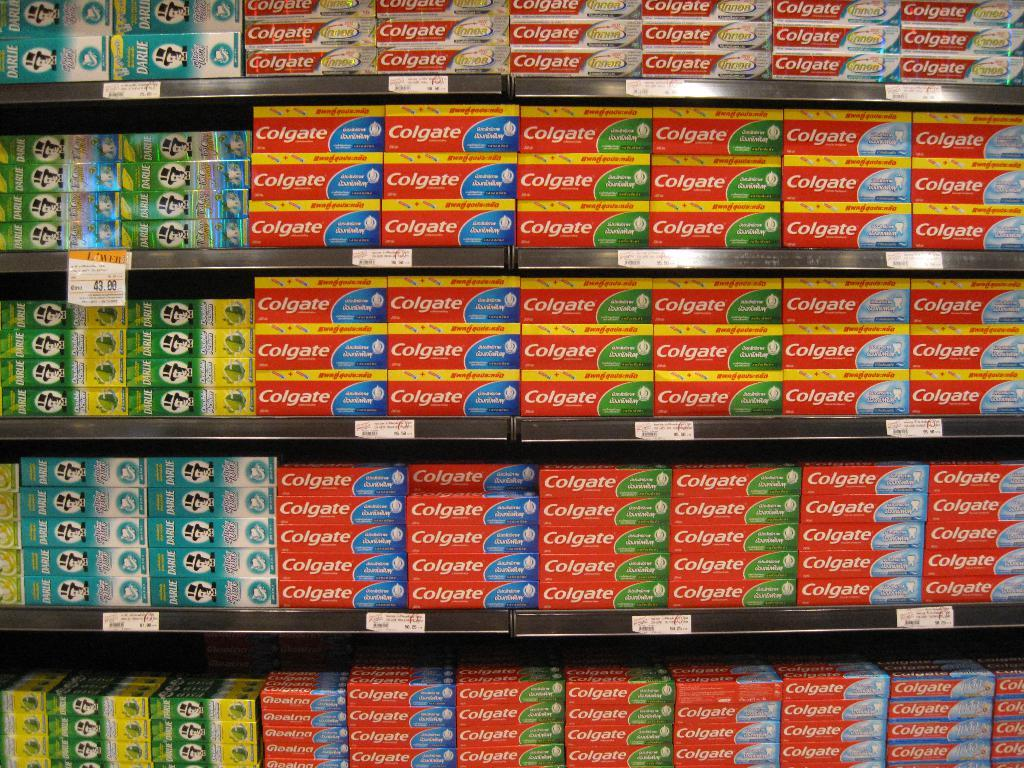<image>
Share a concise interpretation of the image provided. a store shelf with colegate on four different shelves 